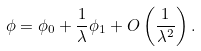<formula> <loc_0><loc_0><loc_500><loc_500>\phi = \phi _ { 0 } + \frac { 1 } { \lambda } \phi _ { 1 } + O \left ( \frac { 1 } { \lambda ^ { 2 } } \right ) .</formula> 